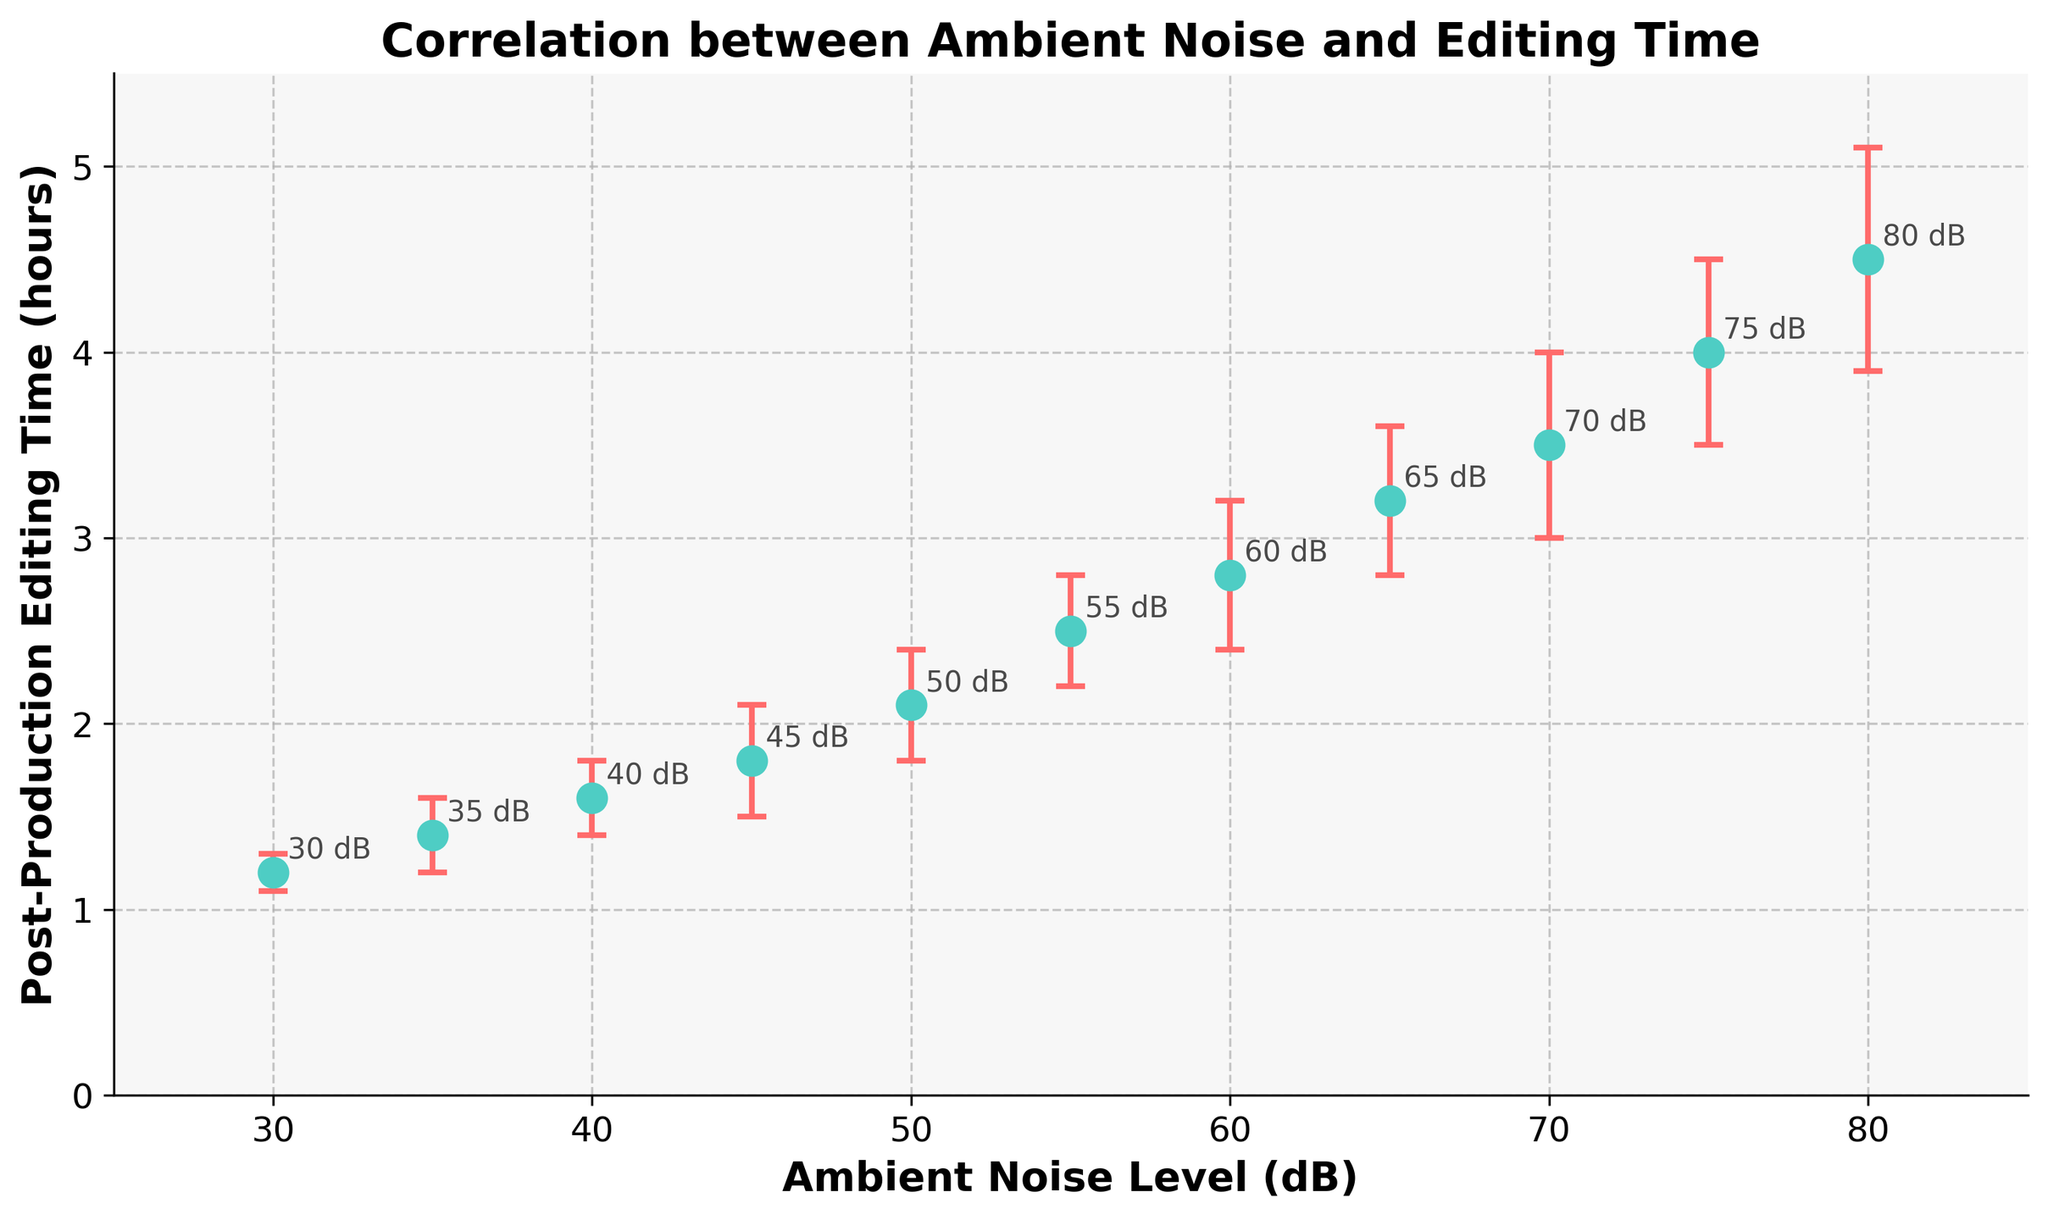What is the title of the chart? The title is displayed at the top of the chart and provides a summary of what the chart represents.
Answer: Correlation between Ambient Noise and Editing Time What is the x-axis label and what does it represent? The label of the x-axis is written horizontally at the bottom of the chart, specifying what is measured along this axis.
Answer: Ambient Noise Level (dB) What is the y-axis label and what does it represent? The label of the y-axis is written vertically along the left side of the chart, specifying what is measured along this axis.
Answer: Post-Production Editing Time (hours) How many data points are plotted on the chart? Each data point is represented as a marker (or dot) on the chart. By counting these markers, one can determine the number of data points.
Answer: 11 Which ambient noise level has the highest post-production editing time, and what is the value? Locate the data point with the highest y-value. The corresponding x-value gives the ambient noise level.
Answer: 80 dB, 4.5 hours At what ambient noise level is post-production editing time 2.1 hours? Locate the y-value of 2.1 hours on the chart, then find the corresponding x-value representing the ambient noise level.
Answer: 50 dB What is the general trend between ambient noise level and post-production editing time? Observe the overall direction in which the data points move as you move from left to right.
Answer: As ambient noise level increases, post-production editing time increases What is the error range for the post-production editing time at 75 dB? Look at the error bar for the data point at 75 dB to determine the range above and below the measurement. The error given is 0.5 hours.
Answer: 3.5 to 4.5 hours Comparing 40 dB and 55 dB, which ambient noise level results in a longer post-production editing time? Check the y-values for the data points at 40 dB and 55 dB, then compare them.
Answer: 55 dB What is the difference in post-production editing time between 60 dB and 30 dB? Find the y-values for 60 dB and 30 dB from the chart, then subtract the lower value from the higher value.
Answer: 1.6 hours (2.8 - 1.2) 